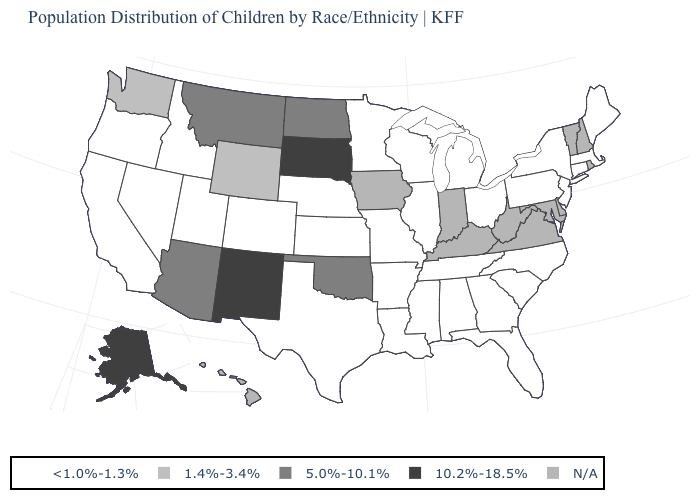Name the states that have a value in the range 1.4%-3.4%?
Be succinct. Washington, Wyoming. What is the value of Delaware?
Write a very short answer. N/A. What is the lowest value in the USA?
Be succinct. <1.0%-1.3%. Among the states that border Montana , which have the lowest value?
Concise answer only. Idaho. Name the states that have a value in the range 5.0%-10.1%?
Quick response, please. Arizona, Montana, North Dakota, Oklahoma. Which states hav the highest value in the South?
Write a very short answer. Oklahoma. Does Kansas have the lowest value in the USA?
Short answer required. Yes. Name the states that have a value in the range 5.0%-10.1%?
Be succinct. Arizona, Montana, North Dakota, Oklahoma. Name the states that have a value in the range 10.2%-18.5%?
Quick response, please. Alaska, New Mexico, South Dakota. Does New Mexico have the highest value in the West?
Answer briefly. Yes. Among the states that border Utah , which have the lowest value?
Write a very short answer. Colorado, Idaho, Nevada. What is the lowest value in the USA?
Give a very brief answer. <1.0%-1.3%. 